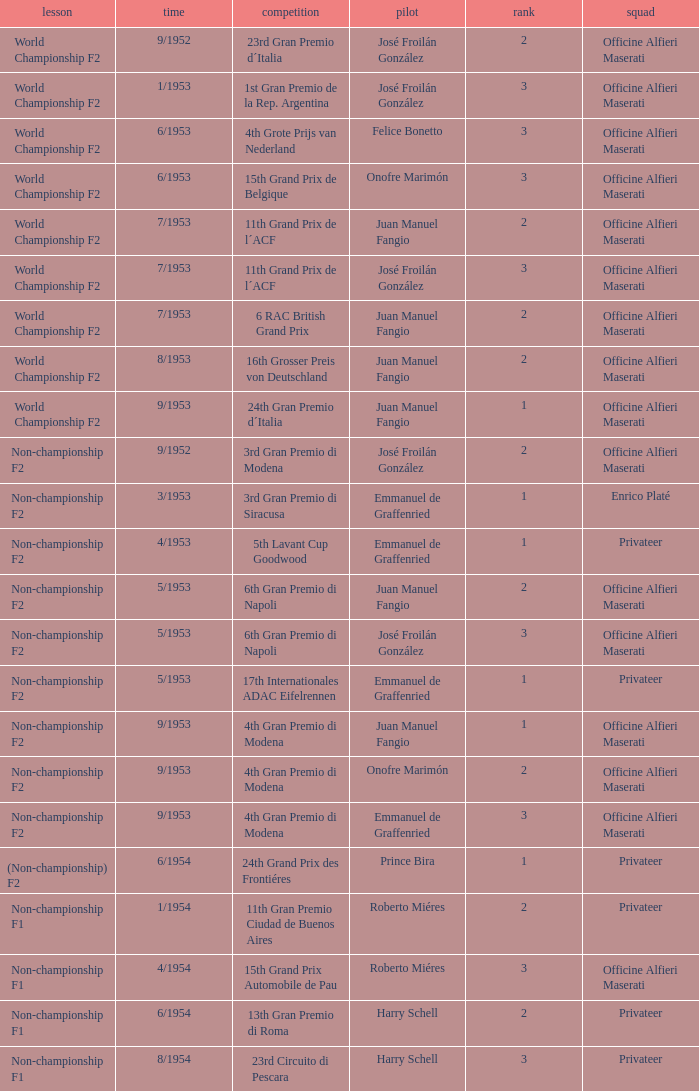Give me the full table as a dictionary. {'header': ['lesson', 'time', 'competition', 'pilot', 'rank', 'squad'], 'rows': [['World Championship F2', '9/1952', '23rd Gran Premio d´Italia', 'José Froilán González', '2', 'Officine Alfieri Maserati'], ['World Championship F2', '1/1953', '1st Gran Premio de la Rep. Argentina', 'José Froilán González', '3', 'Officine Alfieri Maserati'], ['World Championship F2', '6/1953', '4th Grote Prijs van Nederland', 'Felice Bonetto', '3', 'Officine Alfieri Maserati'], ['World Championship F2', '6/1953', '15th Grand Prix de Belgique', 'Onofre Marimón', '3', 'Officine Alfieri Maserati'], ['World Championship F2', '7/1953', '11th Grand Prix de l´ACF', 'Juan Manuel Fangio', '2', 'Officine Alfieri Maserati'], ['World Championship F2', '7/1953', '11th Grand Prix de l´ACF', 'José Froilán González', '3', 'Officine Alfieri Maserati'], ['World Championship F2', '7/1953', '6 RAC British Grand Prix', 'Juan Manuel Fangio', '2', 'Officine Alfieri Maserati'], ['World Championship F2', '8/1953', '16th Grosser Preis von Deutschland', 'Juan Manuel Fangio', '2', 'Officine Alfieri Maserati'], ['World Championship F2', '9/1953', '24th Gran Premio d´Italia', 'Juan Manuel Fangio', '1', 'Officine Alfieri Maserati'], ['Non-championship F2', '9/1952', '3rd Gran Premio di Modena', 'José Froilán González', '2', 'Officine Alfieri Maserati'], ['Non-championship F2', '3/1953', '3rd Gran Premio di Siracusa', 'Emmanuel de Graffenried', '1', 'Enrico Platé'], ['Non-championship F2', '4/1953', '5th Lavant Cup Goodwood', 'Emmanuel de Graffenried', '1', 'Privateer'], ['Non-championship F2', '5/1953', '6th Gran Premio di Napoli', 'Juan Manuel Fangio', '2', 'Officine Alfieri Maserati'], ['Non-championship F2', '5/1953', '6th Gran Premio di Napoli', 'José Froilán González', '3', 'Officine Alfieri Maserati'], ['Non-championship F2', '5/1953', '17th Internationales ADAC Eifelrennen', 'Emmanuel de Graffenried', '1', 'Privateer'], ['Non-championship F2', '9/1953', '4th Gran Premio di Modena', 'Juan Manuel Fangio', '1', 'Officine Alfieri Maserati'], ['Non-championship F2', '9/1953', '4th Gran Premio di Modena', 'Onofre Marimón', '2', 'Officine Alfieri Maserati'], ['Non-championship F2', '9/1953', '4th Gran Premio di Modena', 'Emmanuel de Graffenried', '3', 'Officine Alfieri Maserati'], ['(Non-championship) F2', '6/1954', '24th Grand Prix des Frontiéres', 'Prince Bira', '1', 'Privateer'], ['Non-championship F1', '1/1954', '11th Gran Premio Ciudad de Buenos Aires', 'Roberto Miéres', '2', 'Privateer'], ['Non-championship F1', '4/1954', '15th Grand Prix Automobile de Pau', 'Roberto Miéres', '3', 'Officine Alfieri Maserati'], ['Non-championship F1', '6/1954', '13th Gran Premio di Roma', 'Harry Schell', '2', 'Privateer'], ['Non-championship F1', '8/1954', '23rd Circuito di Pescara', 'Harry Schell', '3', 'Privateer']]} What date has the class of non-championship f2 as well as a driver name josé froilán gonzález that has a position larger than 2? 5/1953. 